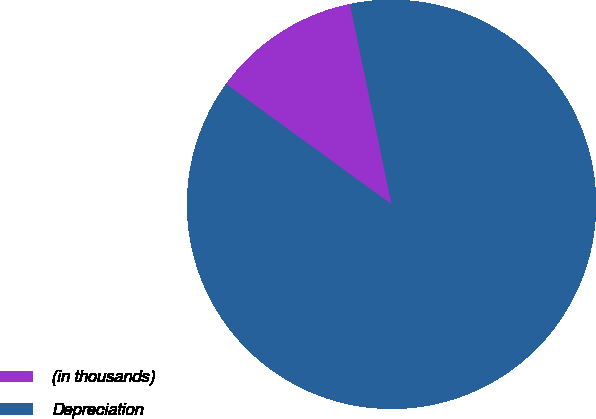Convert chart. <chart><loc_0><loc_0><loc_500><loc_500><pie_chart><fcel>(in thousands)<fcel>Depreciation<nl><fcel>11.74%<fcel>88.26%<nl></chart> 